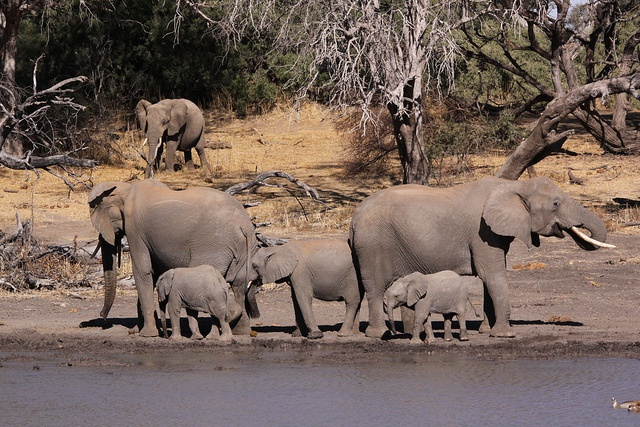Describe the objects in this image and their specific colors. I can see elephant in black, darkgray, and gray tones, elephant in black, gray, and darkgray tones, elephant in black, darkgray, and gray tones, elephant in black, darkgray, and gray tones, and elephant in black, darkgray, and gray tones in this image. 